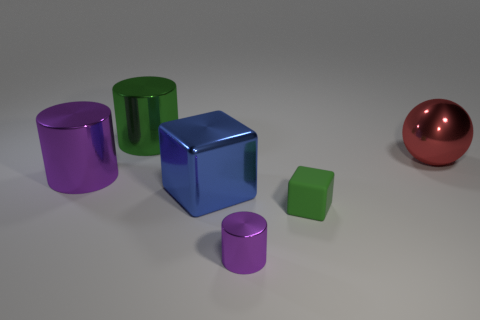What number of metallic objects are either small green blocks or big brown objects?
Make the answer very short. 0. Are there any matte spheres of the same size as the green matte cube?
Keep it short and to the point. No. There is a big thing that is the same color as the small block; what is its shape?
Your answer should be compact. Cylinder. How many cyan metal spheres have the same size as the red metallic object?
Ensure brevity in your answer.  0. Does the purple shiny object that is behind the big blue metal thing have the same size as the cylinder that is behind the big metallic sphere?
Provide a succinct answer. Yes. How many objects are large metallic cubes or cylinders that are behind the red metal thing?
Offer a terse response. 2. What is the color of the small metal object?
Your response must be concise. Purple. What is the material of the cylinder that is to the left of the large green thing that is behind the tiny purple thing that is in front of the large sphere?
Give a very brief answer. Metal. There is a blue object that is made of the same material as the red ball; what is its size?
Give a very brief answer. Large. Are there any small shiny cylinders of the same color as the tiny block?
Provide a short and direct response. No. 